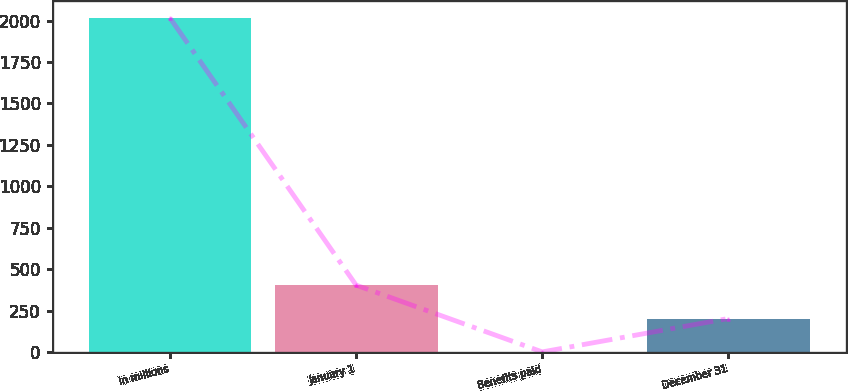Convert chart to OTSL. <chart><loc_0><loc_0><loc_500><loc_500><bar_chart><fcel>in millions<fcel>January 1<fcel>Benefits paid<fcel>December 31<nl><fcel>2015<fcel>404.52<fcel>1.9<fcel>203.21<nl></chart> 